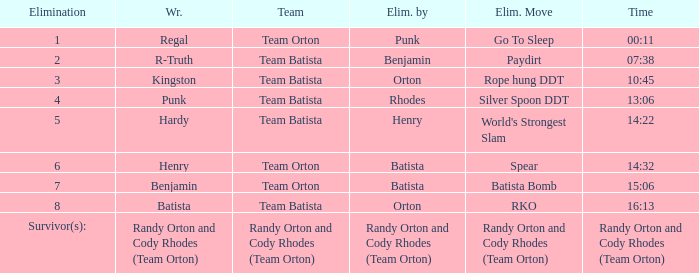What is the Elimination move listed against Regal? Go To Sleep. 